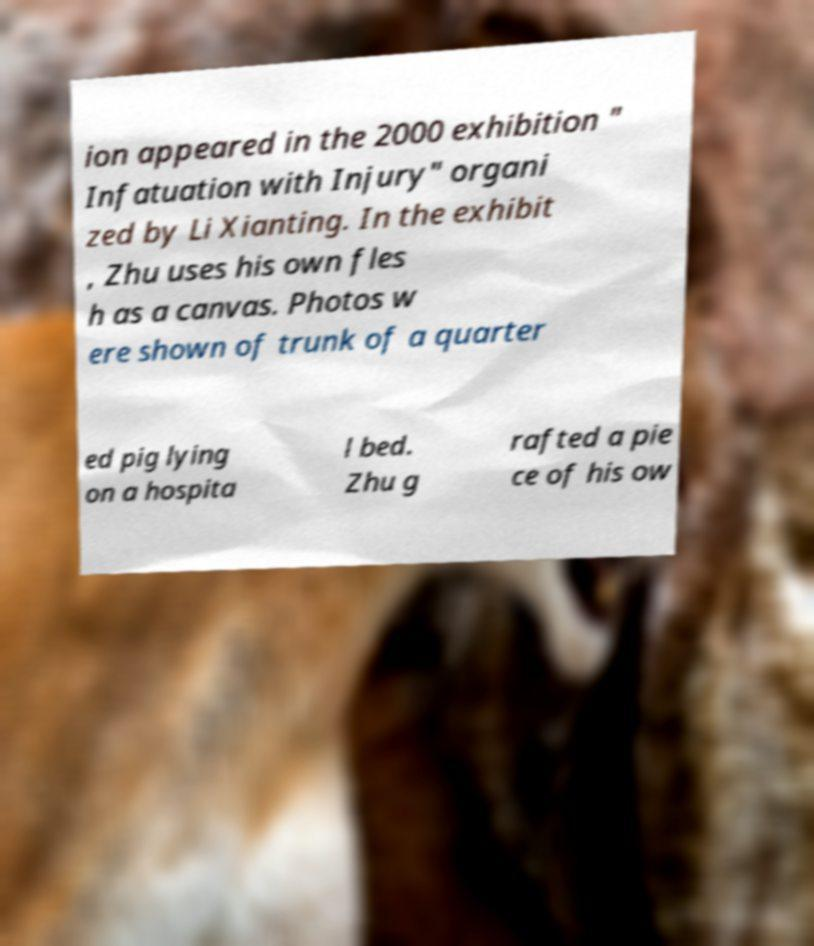Can you accurately transcribe the text from the provided image for me? ion appeared in the 2000 exhibition " Infatuation with Injury" organi zed by Li Xianting. In the exhibit , Zhu uses his own fles h as a canvas. Photos w ere shown of trunk of a quarter ed pig lying on a hospita l bed. Zhu g rafted a pie ce of his ow 